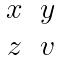<formula> <loc_0><loc_0><loc_500><loc_500>\begin{matrix} x & y \\ z & v \end{matrix}</formula> 